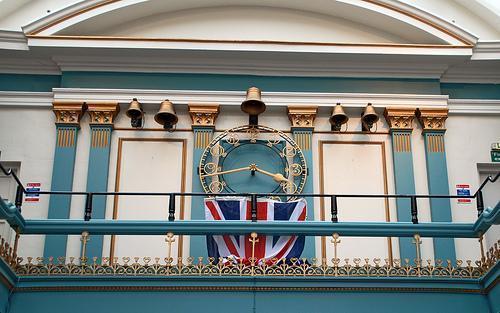How many bells are on the building?
Give a very brief answer. 5. 